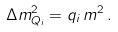Convert formula to latex. <formula><loc_0><loc_0><loc_500><loc_500>\Delta m ^ { 2 } _ { Q _ { i } } = q _ { i } \, m ^ { 2 } \, .</formula> 